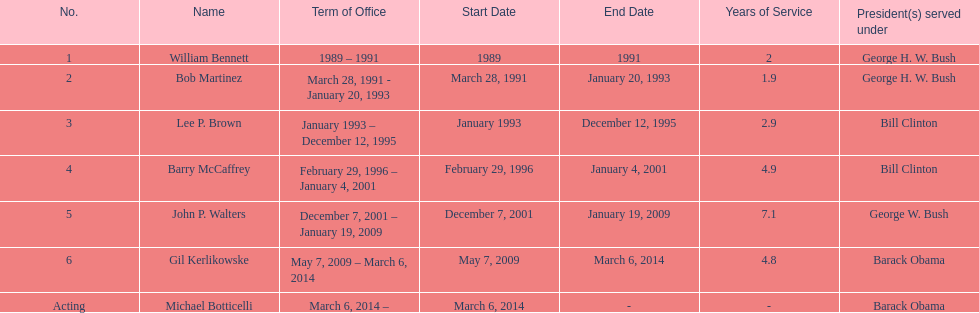How long did the first director serve in office? 2 years. 